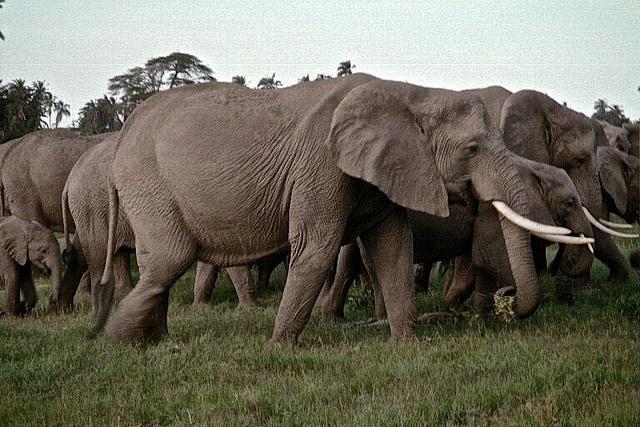How many elephants are there?
Give a very brief answer. 7. 